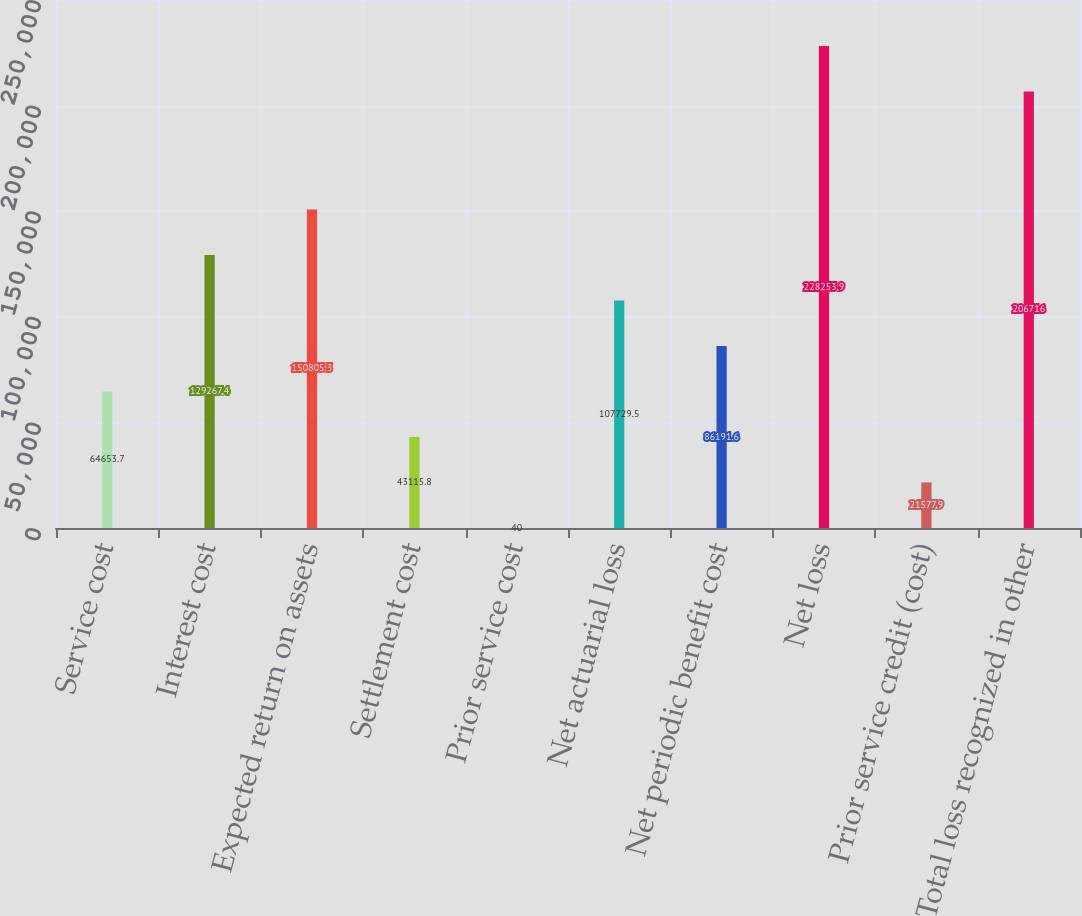Convert chart to OTSL. <chart><loc_0><loc_0><loc_500><loc_500><bar_chart><fcel>Service cost<fcel>Interest cost<fcel>Expected return on assets<fcel>Settlement cost<fcel>Prior service cost<fcel>Net actuarial loss<fcel>Net periodic benefit cost<fcel>Net loss<fcel>Prior service credit (cost)<fcel>Total loss recognized in other<nl><fcel>64653.7<fcel>129267<fcel>150805<fcel>43115.8<fcel>40<fcel>107730<fcel>86191.6<fcel>228254<fcel>21577.9<fcel>206716<nl></chart> 